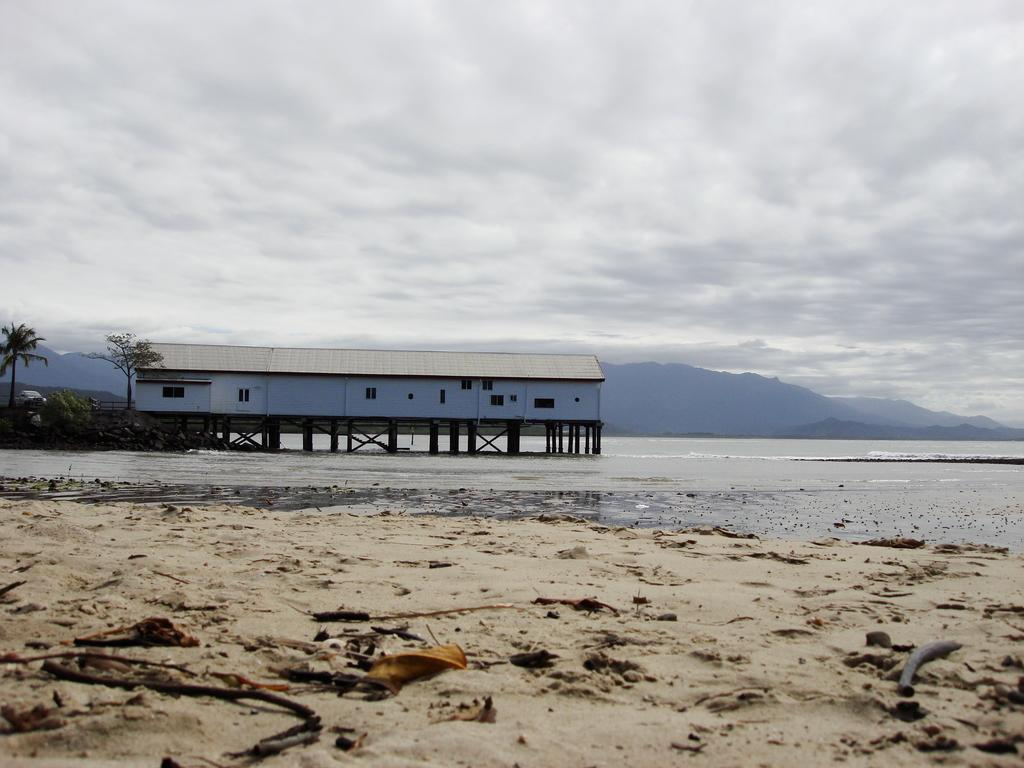What type of terrain is visible in the image? There is sand in the image. What natural feature can be seen in the background of the image? There is a sea in the background of the image. What man-made structure is present in the background of the image? There is a bridge in the background of the image, and a house is on the bridge. What other natural features can be seen in the background of the image? There are mountains, trees, and the sky visible in the background of the image. How many children are playing with the copper twig in the image? There are no children or copper twigs present in the image. 